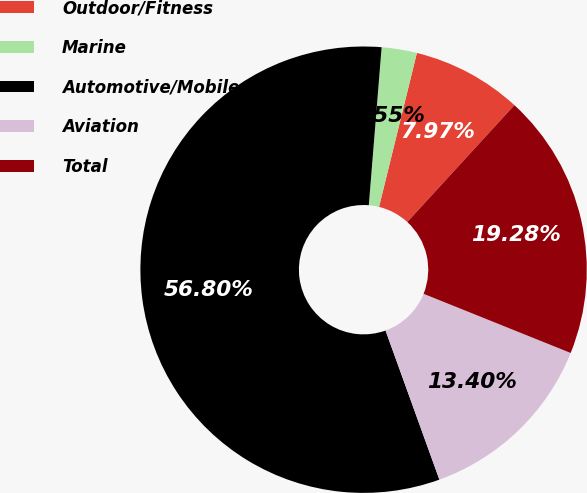<chart> <loc_0><loc_0><loc_500><loc_500><pie_chart><fcel>Outdoor/Fitness<fcel>Marine<fcel>Automotive/Mobile<fcel>Aviation<fcel>Total<nl><fcel>7.97%<fcel>2.55%<fcel>56.81%<fcel>13.4%<fcel>19.28%<nl></chart> 